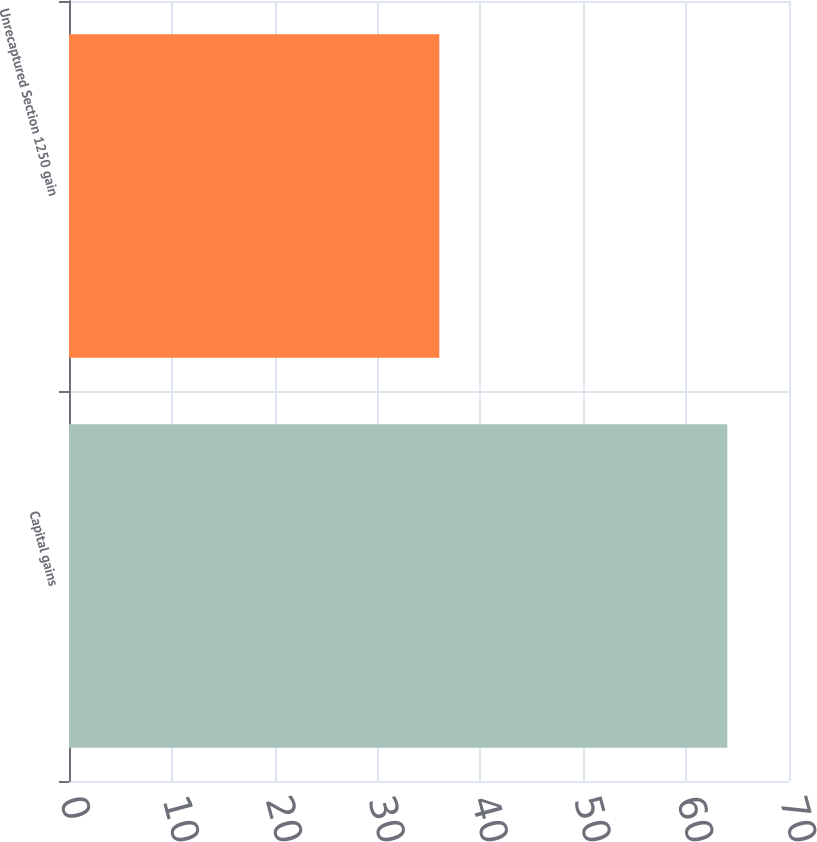Convert chart to OTSL. <chart><loc_0><loc_0><loc_500><loc_500><bar_chart><fcel>Capital gains<fcel>Unrecaptured Section 1250 gain<nl><fcel>64<fcel>36<nl></chart> 